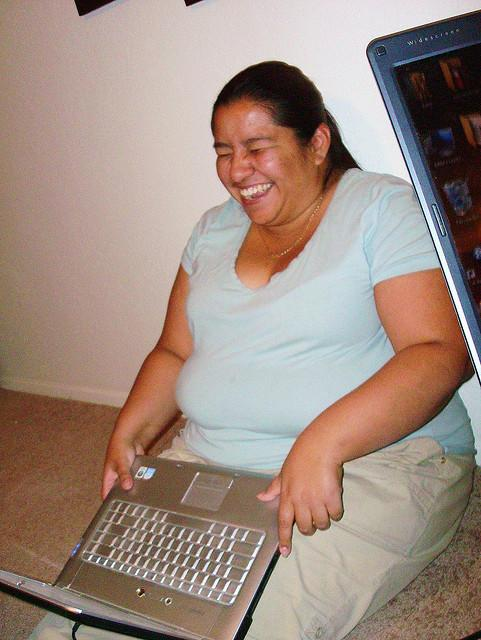What OS is the laptop on the right displaying on its screen? windows 